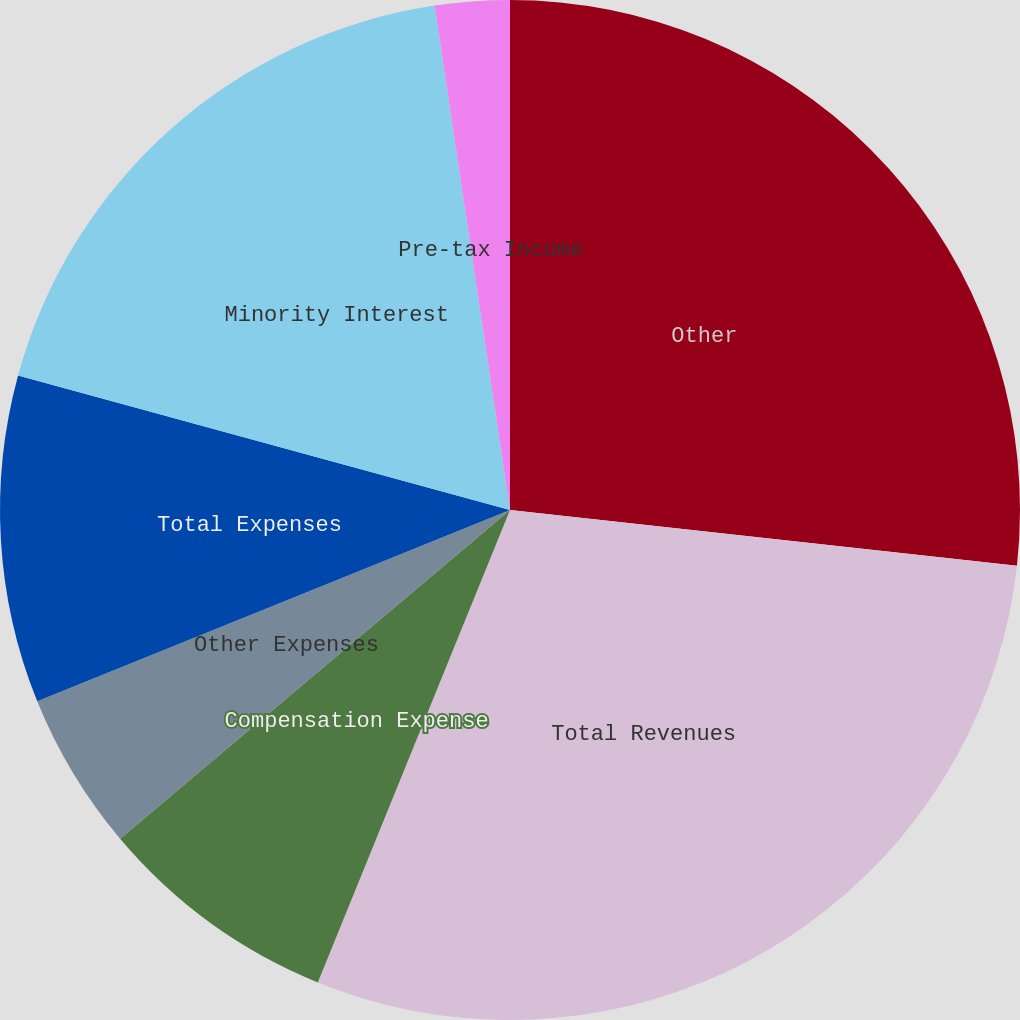Convert chart. <chart><loc_0><loc_0><loc_500><loc_500><pie_chart><fcel>Other<fcel>Total Revenues<fcel>Compensation Expense<fcel>Other Expenses<fcel>Total Expenses<fcel>Minority Interest<fcel>Pre-tax Income<nl><fcel>26.74%<fcel>29.41%<fcel>7.7%<fcel>5.03%<fcel>10.37%<fcel>18.39%<fcel>2.36%<nl></chart> 